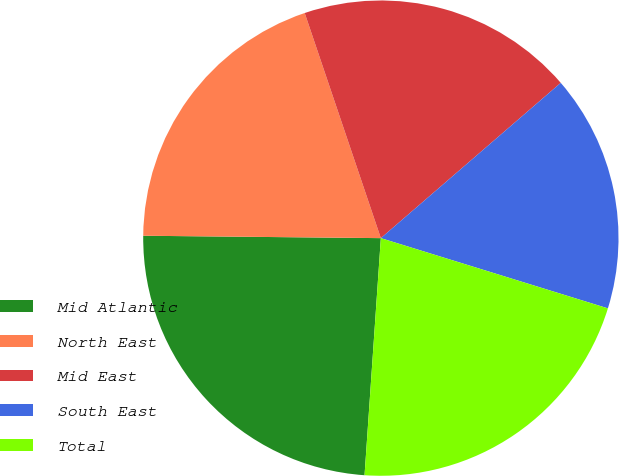Convert chart to OTSL. <chart><loc_0><loc_0><loc_500><loc_500><pie_chart><fcel>Mid Atlantic<fcel>North East<fcel>Mid East<fcel>South East<fcel>Total<nl><fcel>24.07%<fcel>19.65%<fcel>18.86%<fcel>16.11%<fcel>21.32%<nl></chart> 